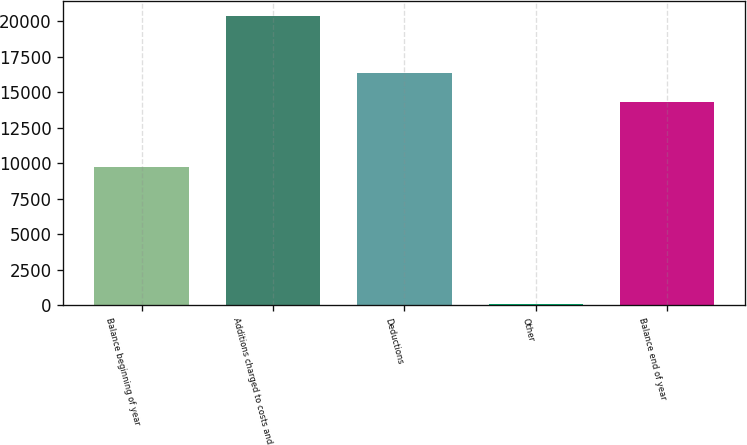Convert chart. <chart><loc_0><loc_0><loc_500><loc_500><bar_chart><fcel>Balance beginning of year<fcel>Additions charged to costs and<fcel>Deductions<fcel>Other<fcel>Balance end of year<nl><fcel>9755<fcel>20387<fcel>16363.8<fcel>109<fcel>14336<nl></chart> 